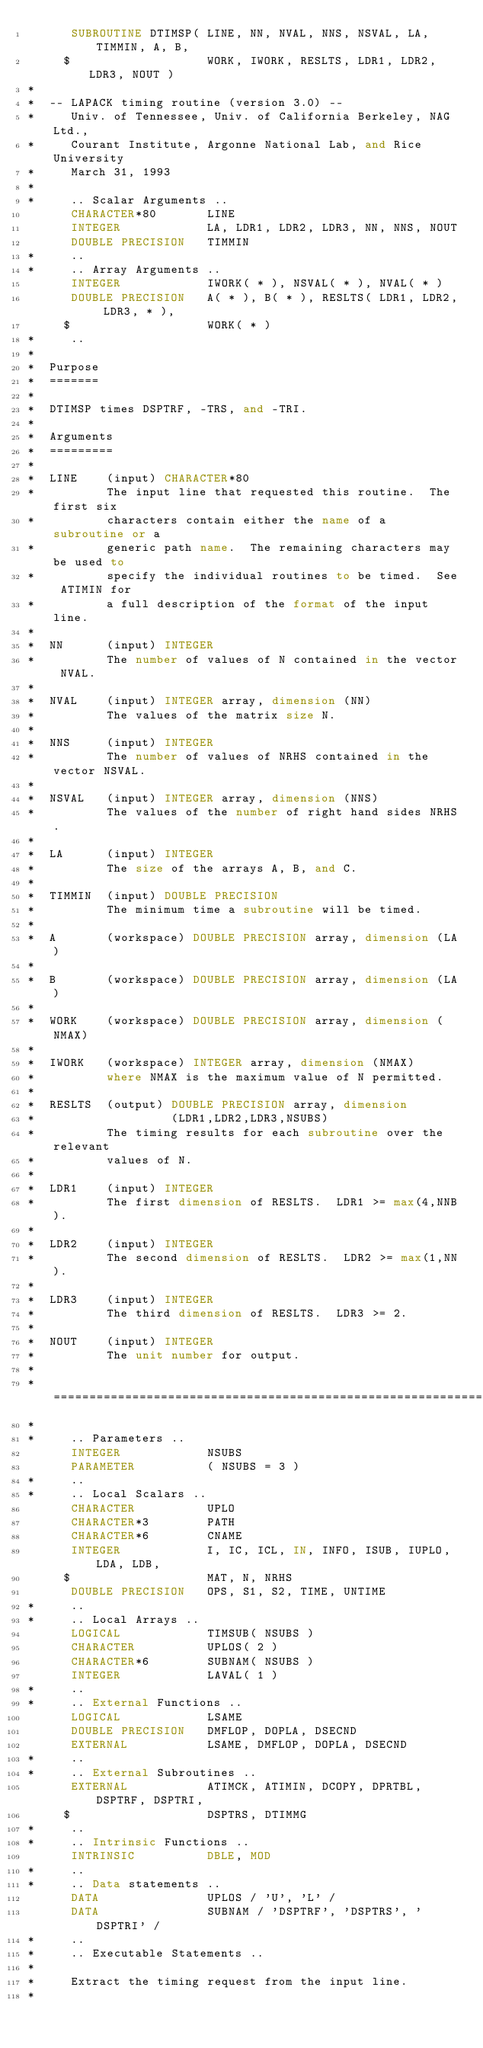<code> <loc_0><loc_0><loc_500><loc_500><_FORTRAN_>      SUBROUTINE DTIMSP( LINE, NN, NVAL, NNS, NSVAL, LA, TIMMIN, A, B,
     $                   WORK, IWORK, RESLTS, LDR1, LDR2, LDR3, NOUT )
*
*  -- LAPACK timing routine (version 3.0) --
*     Univ. of Tennessee, Univ. of California Berkeley, NAG Ltd.,
*     Courant Institute, Argonne National Lab, and Rice University
*     March 31, 1993
*
*     .. Scalar Arguments ..
      CHARACTER*80       LINE
      INTEGER            LA, LDR1, LDR2, LDR3, NN, NNS, NOUT
      DOUBLE PRECISION   TIMMIN
*     ..
*     .. Array Arguments ..
      INTEGER            IWORK( * ), NSVAL( * ), NVAL( * )
      DOUBLE PRECISION   A( * ), B( * ), RESLTS( LDR1, LDR2, LDR3, * ),
     $                   WORK( * )
*     ..
*
*  Purpose
*  =======
*
*  DTIMSP times DSPTRF, -TRS, and -TRI.
*
*  Arguments
*  =========
*
*  LINE    (input) CHARACTER*80
*          The input line that requested this routine.  The first six
*          characters contain either the name of a subroutine or a
*          generic path name.  The remaining characters may be used to
*          specify the individual routines to be timed.  See ATIMIN for
*          a full description of the format of the input line.
*
*  NN      (input) INTEGER
*          The number of values of N contained in the vector NVAL.
*
*  NVAL    (input) INTEGER array, dimension (NN)
*          The values of the matrix size N.
*
*  NNS     (input) INTEGER
*          The number of values of NRHS contained in the vector NSVAL.
*
*  NSVAL   (input) INTEGER array, dimension (NNS)
*          The values of the number of right hand sides NRHS.
*
*  LA      (input) INTEGER
*          The size of the arrays A, B, and C.
*
*  TIMMIN  (input) DOUBLE PRECISION
*          The minimum time a subroutine will be timed.
*
*  A       (workspace) DOUBLE PRECISION array, dimension (LA)
*
*  B       (workspace) DOUBLE PRECISION array, dimension (LA)
*
*  WORK    (workspace) DOUBLE PRECISION array, dimension (NMAX)
*
*  IWORK   (workspace) INTEGER array, dimension (NMAX)
*          where NMAX is the maximum value of N permitted.
*
*  RESLTS  (output) DOUBLE PRECISION array, dimension
*                   (LDR1,LDR2,LDR3,NSUBS)
*          The timing results for each subroutine over the relevant
*          values of N.
*
*  LDR1    (input) INTEGER
*          The first dimension of RESLTS.  LDR1 >= max(4,NNB).
*
*  LDR2    (input) INTEGER
*          The second dimension of RESLTS.  LDR2 >= max(1,NN).
*
*  LDR3    (input) INTEGER
*          The third dimension of RESLTS.  LDR3 >= 2.
*
*  NOUT    (input) INTEGER
*          The unit number for output.
*
*  =====================================================================
*
*     .. Parameters ..
      INTEGER            NSUBS
      PARAMETER          ( NSUBS = 3 )
*     ..
*     .. Local Scalars ..
      CHARACTER          UPLO
      CHARACTER*3        PATH
      CHARACTER*6        CNAME
      INTEGER            I, IC, ICL, IN, INFO, ISUB, IUPLO, LDA, LDB,
     $                   MAT, N, NRHS
      DOUBLE PRECISION   OPS, S1, S2, TIME, UNTIME
*     ..
*     .. Local Arrays ..
      LOGICAL            TIMSUB( NSUBS )
      CHARACTER          UPLOS( 2 )
      CHARACTER*6        SUBNAM( NSUBS )
      INTEGER            LAVAL( 1 )
*     ..
*     .. External Functions ..
      LOGICAL            LSAME
      DOUBLE PRECISION   DMFLOP, DOPLA, DSECND
      EXTERNAL           LSAME, DMFLOP, DOPLA, DSECND
*     ..
*     .. External Subroutines ..
      EXTERNAL           ATIMCK, ATIMIN, DCOPY, DPRTBL, DSPTRF, DSPTRI,
     $                   DSPTRS, DTIMMG
*     ..
*     .. Intrinsic Functions ..
      INTRINSIC          DBLE, MOD
*     ..
*     .. Data statements ..
      DATA               UPLOS / 'U', 'L' /
      DATA               SUBNAM / 'DSPTRF', 'DSPTRS', 'DSPTRI' /
*     ..
*     .. Executable Statements ..
*
*     Extract the timing request from the input line.
*</code> 